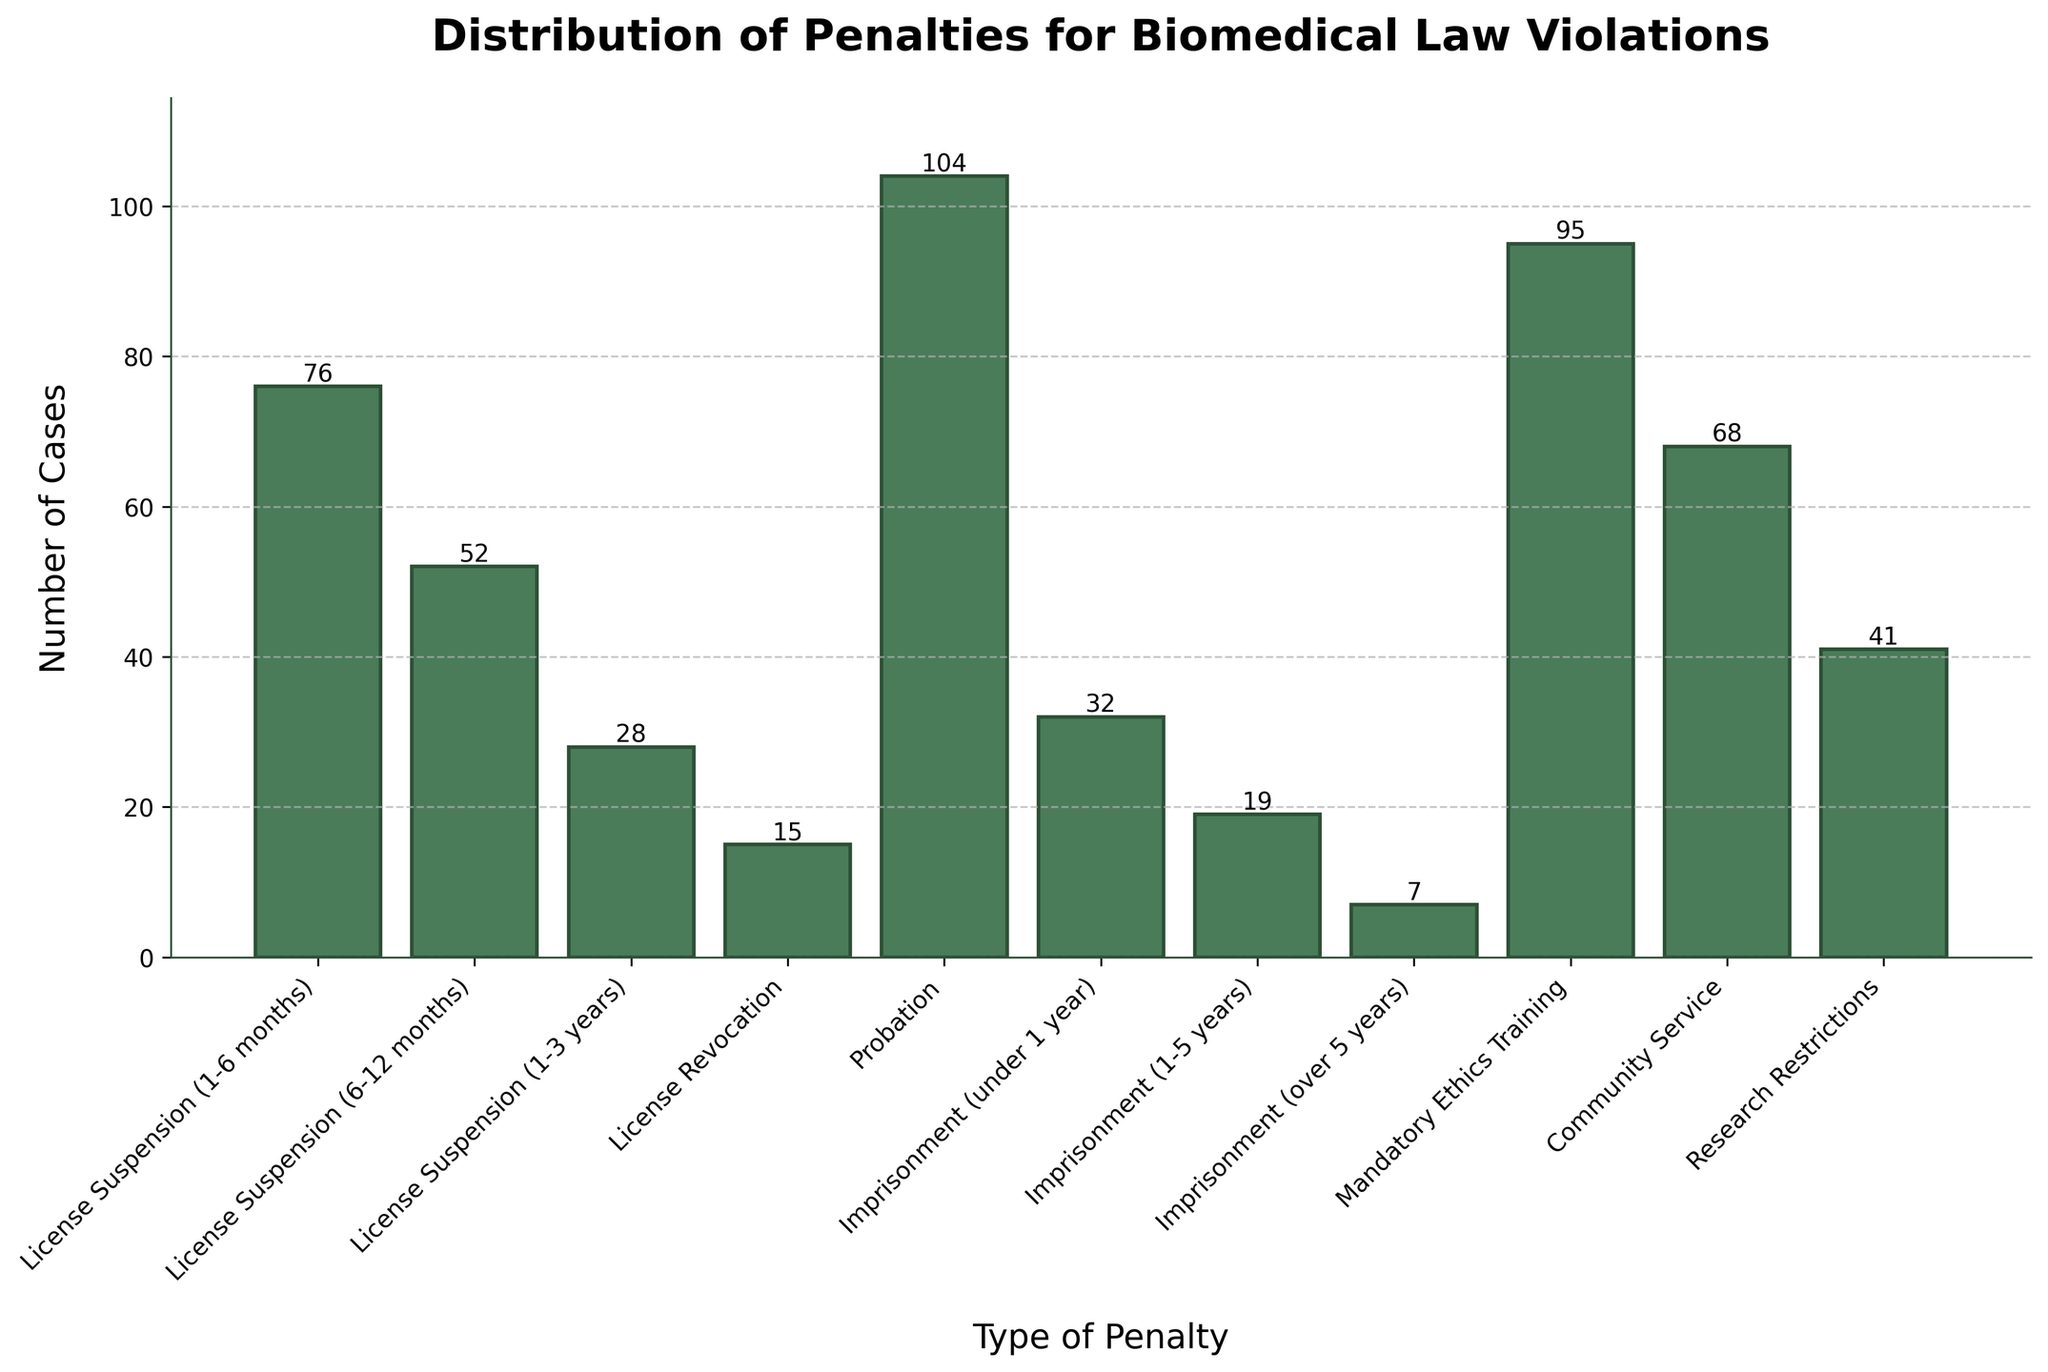What is the most common penalty imposed for biomedical law violations? The bar representing "Probation" has the highest height, visualizing 104 cases.
Answer: Probation Which penalty is less common, imprisonment (under 1 year) or imprisonment (1-5 years)? The figure shows the bar for imprisonment (under 1 year) at 32 cases and the bar for imprisonment (1-5 years) at 19 cases, indicating imprisonment (1-5 years) is less common.
Answer: Imprisonment (1-5 years) How many more cases involve mandatory ethics training compared to license revocation? Mandatory ethics training has 95 cases, and license revocation has 15 cases. Subtracting the two gives 95 - 15 = 80 cases.
Answer: 80 What is the total number of cases involving any form of imprisonment? Sum the number of cases for the bars imprisonment (under 1 year) (32), (1-5 years) (19), and (over 5 years) (7). The total is 32 + 19 + 7 = 58 cases.
Answer: 58 Rank the penalties from most to least common based on the number of cases. Sorting the bars based on their heights: Probation (104), Mandatory Ethics Training (95), License Suspension (1-6 months) (76), Community Service (68), License Suspension (6-12 months) (52), Research Restrictions (41), Imprisonment (under 1 year) (32), License Suspension (1-3 years) (28), Imprisonment (1-5 years) (19), License Revocation (15), Imprisonment (over 5 years) (7).
Answer: Probation > Mandatory Ethics Training > License Suspension (1-6 months) > Community Service > License Suspension (6-12 months) > Research Restrictions > Imprisonment (under 1 year) > License Suspension (1-3 years) > Imprisonment (1-5 years) > License Revocation > Imprisonment (over 5 years) Is license suspension (1-6 months) more common than community service? The bar for license suspension (1-6 months) is taller, indicating 76 cases, while the bar for community service shows 68 cases. Thus, license suspension (1-6 months) is more common.
Answer: Yes What is the sum of all cases involving any form of license suspension? Add the cases for license suspension (1-6 months) (76), (6-12 months) (52), and (1-3 years) (28): 76 + 52 + 28 = 156.
Answer: 156 Which penalty has the smallest number of cases? The figure shows the bar for imprisonment (over 5 years) with the lowest height of 7 cases.
Answer: Imprisonment (over 5 years) What is the median number of cases for all penalties? Ordering the number of cases: 7, 15, 19, 28, 32, 41, 52, 68, 76, 95, 104. With 11 data points, the median is the 6th value: 41 (Research Restrictions).
Answer: 41 